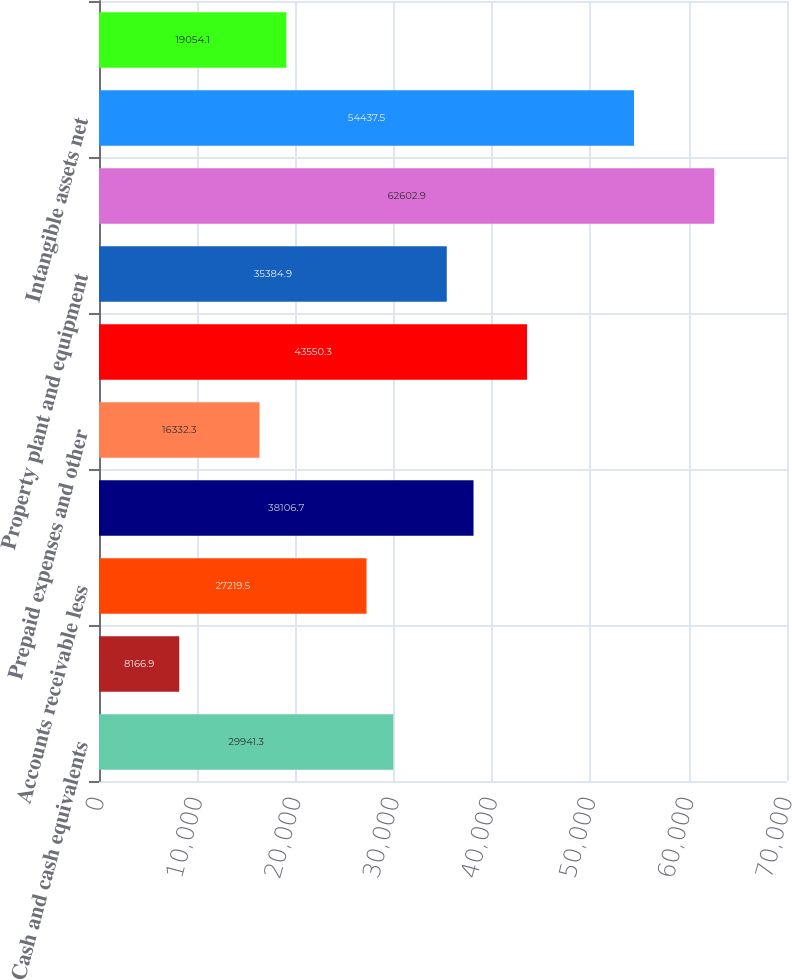<chart> <loc_0><loc_0><loc_500><loc_500><bar_chart><fcel>Cash and cash equivalents<fcel>Short-term investments<fcel>Accounts receivable less<fcel>Inventories<fcel>Prepaid expenses and other<fcel>Total Current Assets<fcel>Property plant and equipment<fcel>Goodwill<fcel>Intangible assets net<fcel>Other assets<nl><fcel>29941.3<fcel>8166.9<fcel>27219.5<fcel>38106.7<fcel>16332.3<fcel>43550.3<fcel>35384.9<fcel>62602.9<fcel>54437.5<fcel>19054.1<nl></chart> 